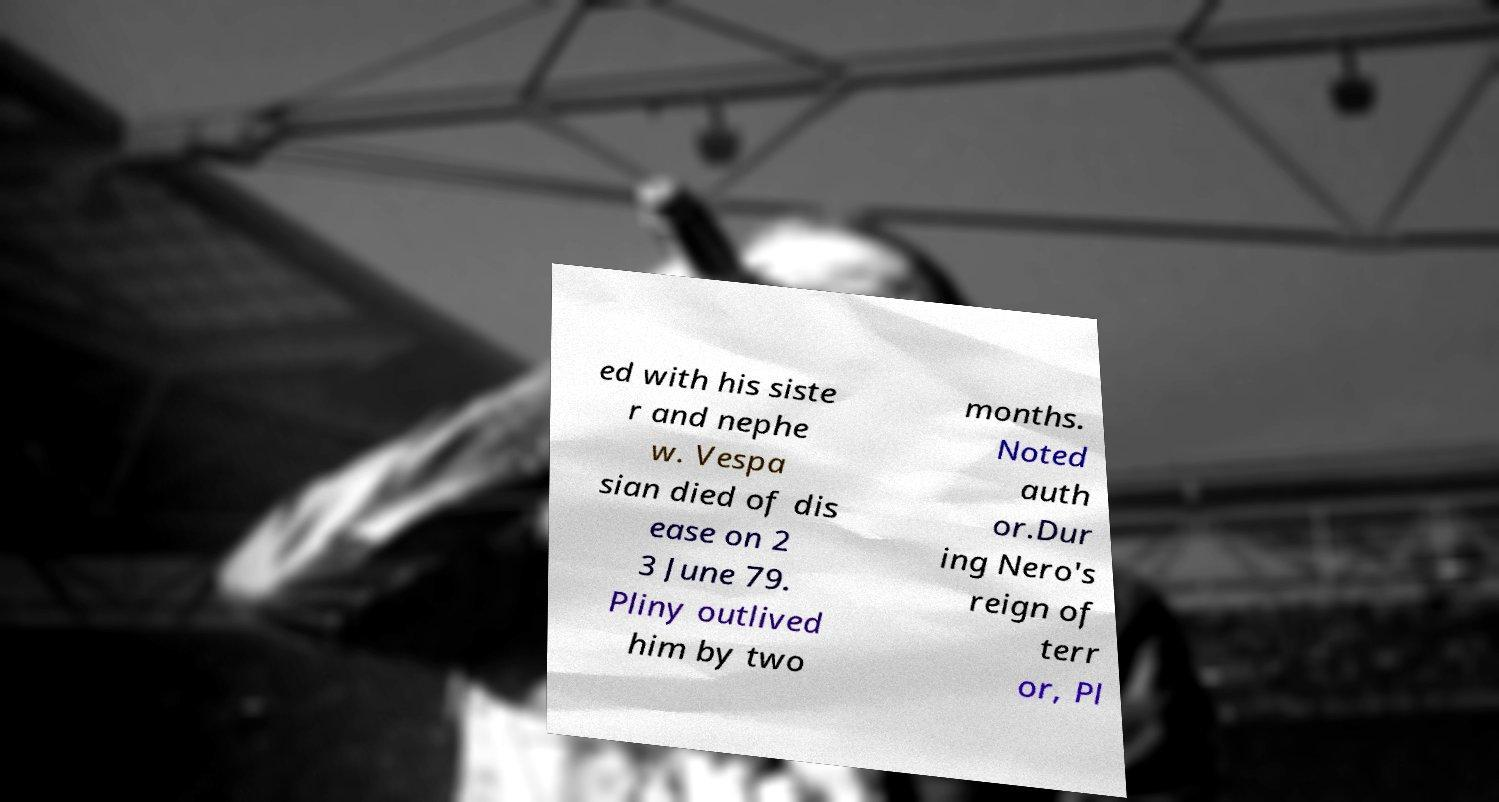Please read and relay the text visible in this image. What does it say? ed with his siste r and nephe w. Vespa sian died of dis ease on 2 3 June 79. Pliny outlived him by two months. Noted auth or.Dur ing Nero's reign of terr or, Pl 